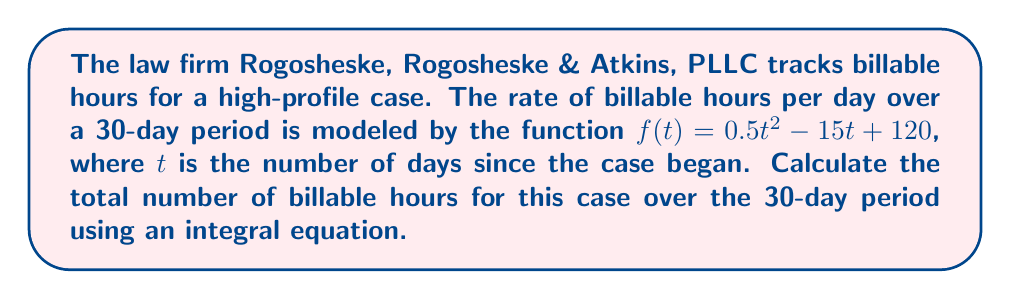Teach me how to tackle this problem. To determine the total number of billable hours over the 30-day period, we need to calculate the area under the curve represented by the function $f(t) = 0.5t^2 - 15t + 120$ from $t = 0$ to $t = 30$. This can be done using a definite integral:

1) Set up the integral equation:
   $$\int_0^{30} (0.5t^2 - 15t + 120) \, dt$$

2) Integrate the function:
   $$\left[ \frac{1}{6}t^3 - \frac{15}{2}t^2 + 120t \right]_0^{30}$$

3) Evaluate the integral:
   $$\left(\frac{1}{6}(30^3) - \frac{15}{2}(30^2) + 120(30)\right) - \left(\frac{1}{6}(0^3) - \frac{15}{2}(0^2) + 120(0)\right)$$

4) Simplify:
   $$\left(4500 - 6750 + 3600\right) - (0)$$
   $$= 1350$$

Therefore, the total number of billable hours over the 30-day period is 1,350 hours.
Answer: 1,350 hours 